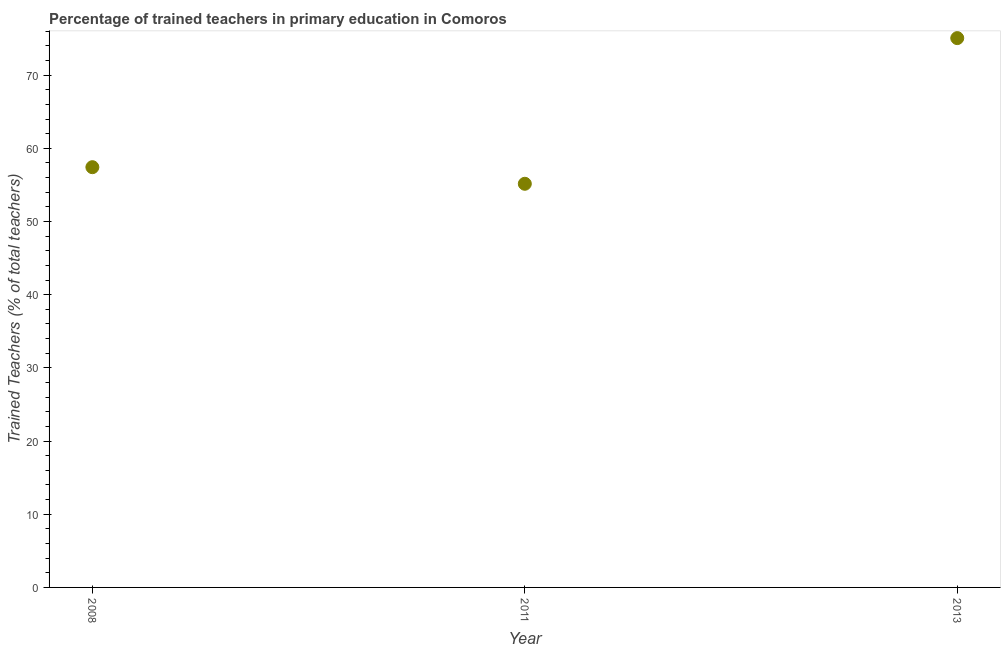What is the percentage of trained teachers in 2013?
Ensure brevity in your answer.  75.06. Across all years, what is the maximum percentage of trained teachers?
Make the answer very short. 75.06. Across all years, what is the minimum percentage of trained teachers?
Your answer should be compact. 55.15. In which year was the percentage of trained teachers maximum?
Your answer should be very brief. 2013. What is the sum of the percentage of trained teachers?
Your answer should be compact. 187.63. What is the difference between the percentage of trained teachers in 2011 and 2013?
Provide a succinct answer. -19.9. What is the average percentage of trained teachers per year?
Provide a short and direct response. 62.54. What is the median percentage of trained teachers?
Your answer should be very brief. 57.42. In how many years, is the percentage of trained teachers greater than 46 %?
Provide a succinct answer. 3. Do a majority of the years between 2013 and 2008 (inclusive) have percentage of trained teachers greater than 2 %?
Give a very brief answer. No. What is the ratio of the percentage of trained teachers in 2008 to that in 2013?
Offer a very short reply. 0.77. Is the percentage of trained teachers in 2011 less than that in 2013?
Provide a succinct answer. Yes. What is the difference between the highest and the second highest percentage of trained teachers?
Keep it short and to the point. 17.64. What is the difference between the highest and the lowest percentage of trained teachers?
Make the answer very short. 19.9. What is the difference between two consecutive major ticks on the Y-axis?
Provide a succinct answer. 10. Does the graph contain grids?
Make the answer very short. No. What is the title of the graph?
Provide a succinct answer. Percentage of trained teachers in primary education in Comoros. What is the label or title of the Y-axis?
Offer a very short reply. Trained Teachers (% of total teachers). What is the Trained Teachers (% of total teachers) in 2008?
Offer a terse response. 57.42. What is the Trained Teachers (% of total teachers) in 2011?
Your answer should be very brief. 55.15. What is the Trained Teachers (% of total teachers) in 2013?
Offer a very short reply. 75.06. What is the difference between the Trained Teachers (% of total teachers) in 2008 and 2011?
Make the answer very short. 2.27. What is the difference between the Trained Teachers (% of total teachers) in 2008 and 2013?
Ensure brevity in your answer.  -17.64. What is the difference between the Trained Teachers (% of total teachers) in 2011 and 2013?
Give a very brief answer. -19.9. What is the ratio of the Trained Teachers (% of total teachers) in 2008 to that in 2011?
Provide a short and direct response. 1.04. What is the ratio of the Trained Teachers (% of total teachers) in 2008 to that in 2013?
Make the answer very short. 0.77. What is the ratio of the Trained Teachers (% of total teachers) in 2011 to that in 2013?
Offer a terse response. 0.73. 